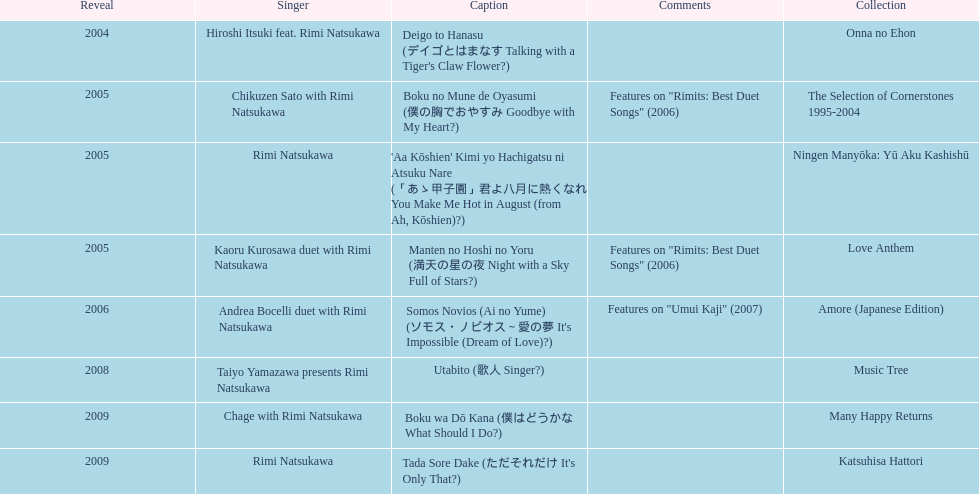Which title has the same notes as night with a sky full of stars? Boku no Mune de Oyasumi (僕の胸でおやすみ Goodbye with My Heart?). 